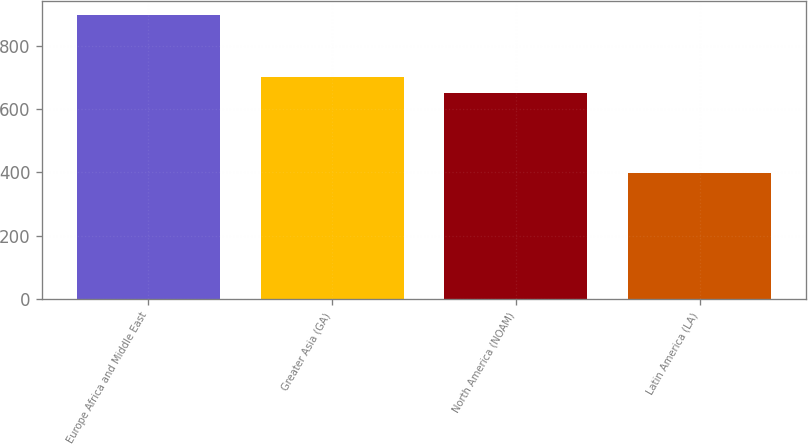Convert chart. <chart><loc_0><loc_0><loc_500><loc_500><bar_chart><fcel>Europe Africa and Middle East<fcel>Greater Asia (GA)<fcel>North America (NOAM)<fcel>Latin America (LA)<nl><fcel>897<fcel>700.9<fcel>651<fcel>398<nl></chart> 